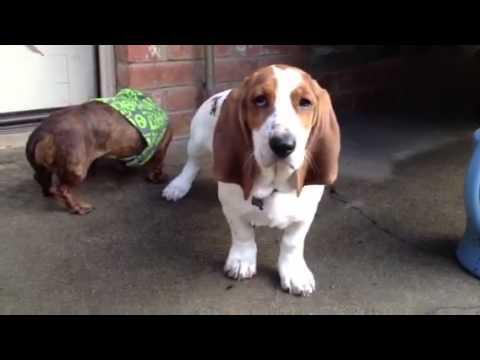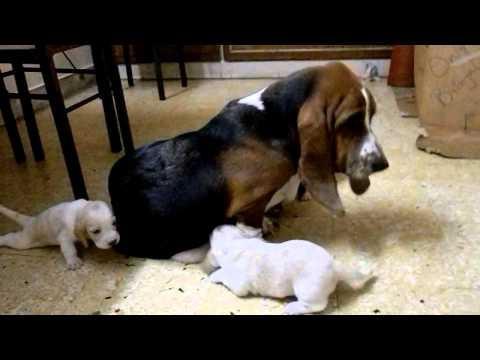The first image is the image on the left, the second image is the image on the right. For the images displayed, is the sentence "There is at least two dogs in the right image." factually correct? Answer yes or no. Yes. The first image is the image on the left, the second image is the image on the right. For the images displayed, is the sentence "At least one of the dogs is lying down with its belly on the floor." factually correct? Answer yes or no. No. 